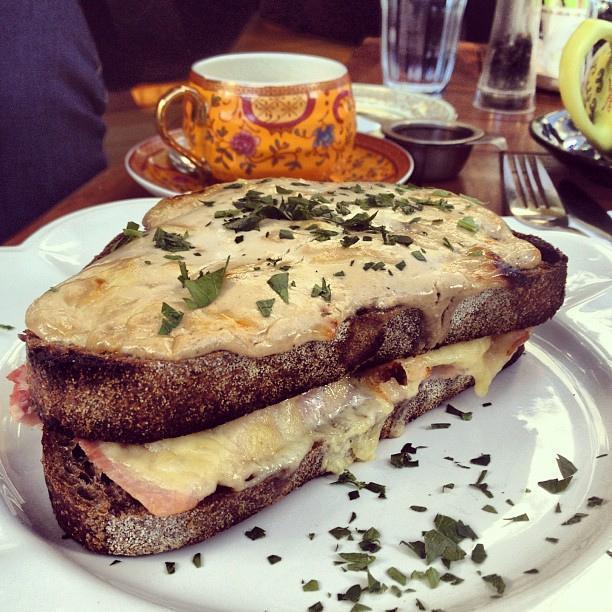What is in the sandwich?
Choose the right answer from the provided options to respond to the question.
Options: Cheese, pork chop, purple onion, bagel. Cheese. 